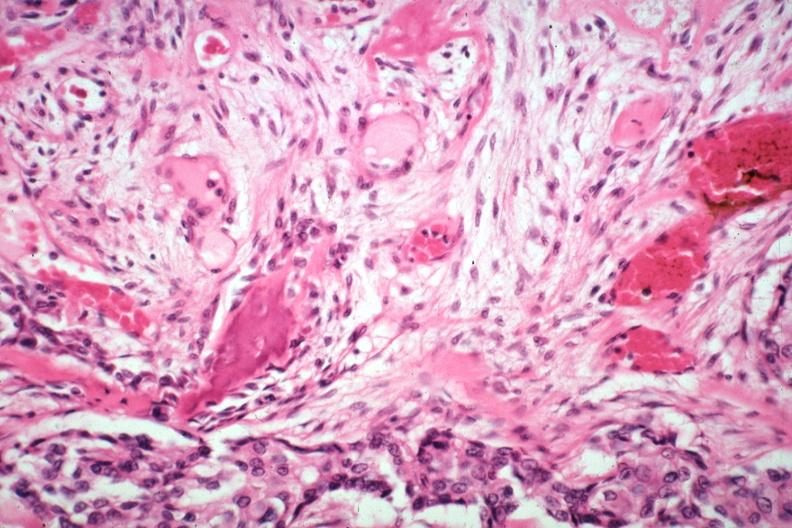s joints present?
Answer the question using a single word or phrase. Yes 